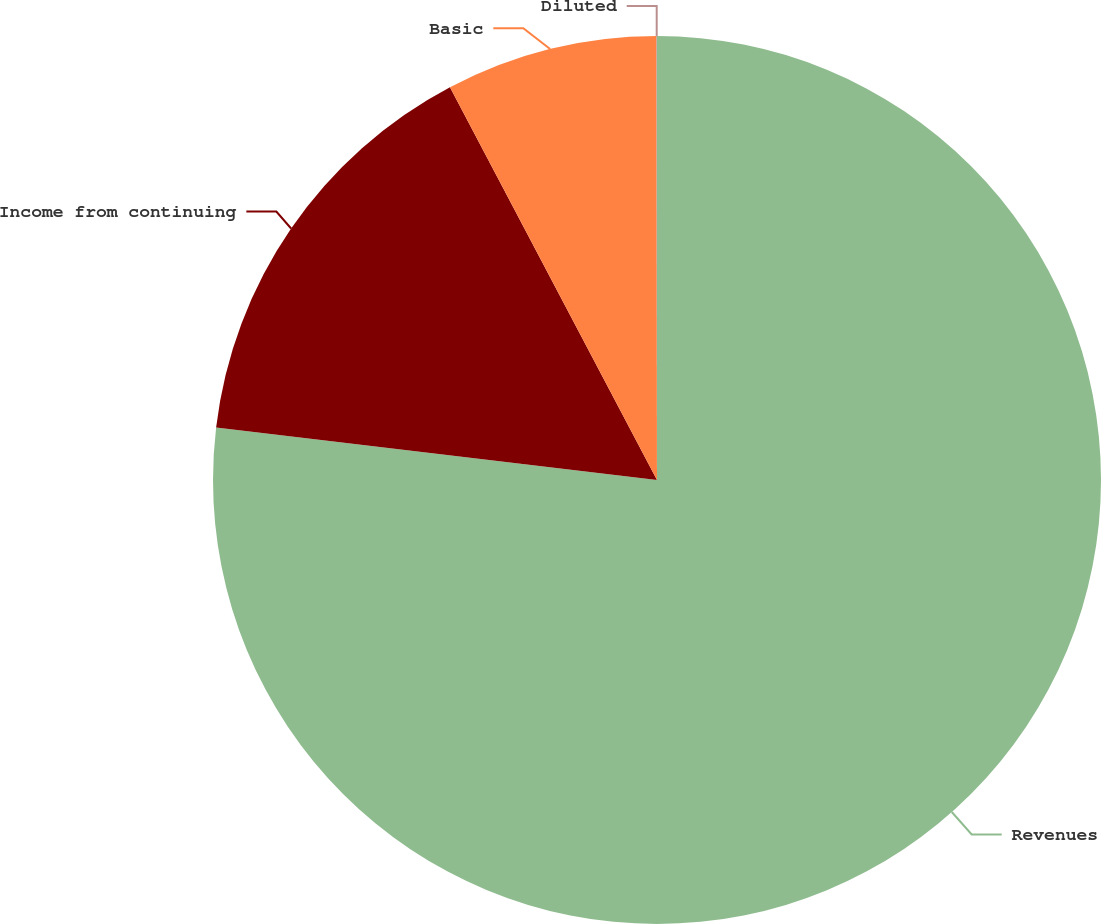Convert chart to OTSL. <chart><loc_0><loc_0><loc_500><loc_500><pie_chart><fcel>Revenues<fcel>Income from continuing<fcel>Basic<fcel>Diluted<nl><fcel>76.89%<fcel>15.39%<fcel>7.7%<fcel>0.02%<nl></chart> 